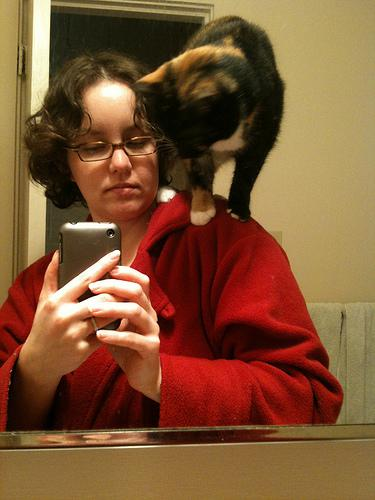Question: what color is the lady's robe?
Choices:
A. Purple.
B. Red.
C. Pink.
D. White.
Answer with the letter. Answer: B Question: how many cats?
Choices:
A. 3.
B. 5.
C. 1.
D. 4.
Answer with the letter. Answer: C Question: what is the lady doing?
Choices:
A. Being a stupid millienial.
B. Holding her phone.
C. Talking.
D. Taking a selfie.
Answer with the letter. Answer: D Question: who is the lady taking a picture of?
Choices:
A. Her friends.
B. Her kid.
C. Herself.
D. Her big zit.
Answer with the letter. Answer: C 